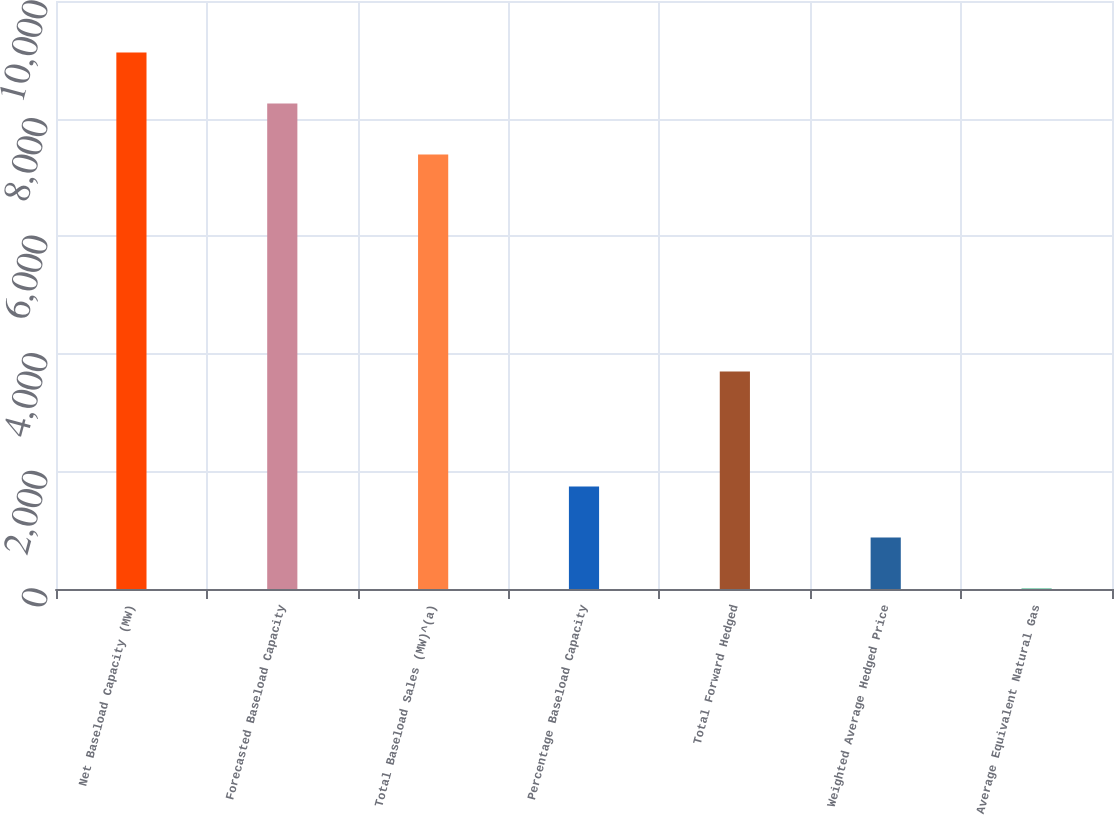Convert chart. <chart><loc_0><loc_0><loc_500><loc_500><bar_chart><fcel>Net Baseload Capacity (MW)<fcel>Forecasted Baseload Capacity<fcel>Total Baseload Sales (MW)^(a)<fcel>Percentage Baseload Capacity<fcel>Total Forward Hedged<fcel>Weighted Average Hedged Price<fcel>Average Equivalent Natural Gas<nl><fcel>9125.54<fcel>8257.77<fcel>7390<fcel>1742.84<fcel>3701<fcel>875.07<fcel>7.3<nl></chart> 